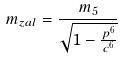<formula> <loc_0><loc_0><loc_500><loc_500>m _ { z a l } = \frac { m _ { 5 } } { \sqrt { 1 - \frac { p ^ { 6 } } { c ^ { 6 } } } }</formula> 